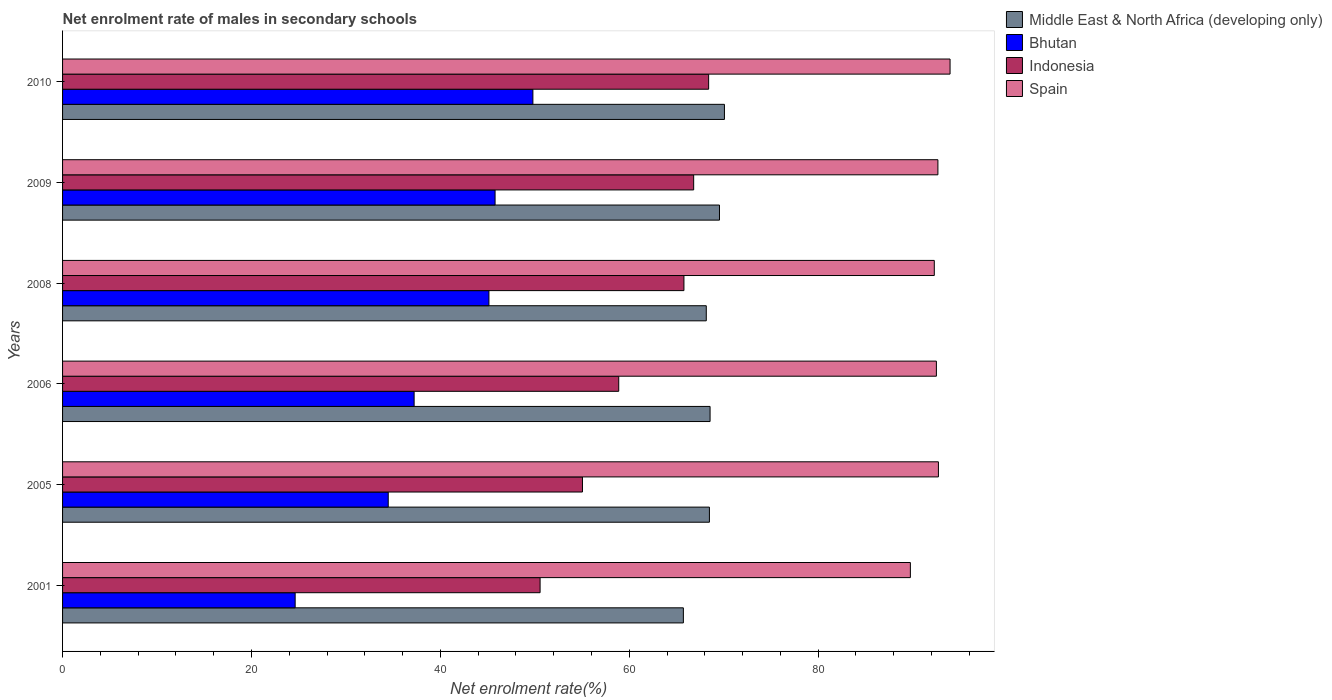How many groups of bars are there?
Provide a succinct answer. 6. Are the number of bars per tick equal to the number of legend labels?
Your response must be concise. Yes. Are the number of bars on each tick of the Y-axis equal?
Keep it short and to the point. Yes. What is the net enrolment rate of males in secondary schools in Bhutan in 2005?
Ensure brevity in your answer.  34.48. Across all years, what is the maximum net enrolment rate of males in secondary schools in Spain?
Your response must be concise. 93.97. Across all years, what is the minimum net enrolment rate of males in secondary schools in Indonesia?
Make the answer very short. 50.56. What is the total net enrolment rate of males in secondary schools in Indonesia in the graph?
Your answer should be very brief. 365.52. What is the difference between the net enrolment rate of males in secondary schools in Bhutan in 2006 and that in 2010?
Provide a succinct answer. -12.57. What is the difference between the net enrolment rate of males in secondary schools in Bhutan in 2005 and the net enrolment rate of males in secondary schools in Middle East & North Africa (developing only) in 2009?
Ensure brevity in your answer.  -35.07. What is the average net enrolment rate of males in secondary schools in Indonesia per year?
Your response must be concise. 60.92. In the year 2001, what is the difference between the net enrolment rate of males in secondary schools in Middle East & North Africa (developing only) and net enrolment rate of males in secondary schools in Bhutan?
Provide a succinct answer. 41.11. In how many years, is the net enrolment rate of males in secondary schools in Spain greater than 92 %?
Keep it short and to the point. 5. What is the ratio of the net enrolment rate of males in secondary schools in Middle East & North Africa (developing only) in 2005 to that in 2010?
Your answer should be very brief. 0.98. What is the difference between the highest and the second highest net enrolment rate of males in secondary schools in Indonesia?
Provide a short and direct response. 1.59. What is the difference between the highest and the lowest net enrolment rate of males in secondary schools in Spain?
Provide a short and direct response. 4.2. Is it the case that in every year, the sum of the net enrolment rate of males in secondary schools in Middle East & North Africa (developing only) and net enrolment rate of males in secondary schools in Spain is greater than the sum of net enrolment rate of males in secondary schools in Bhutan and net enrolment rate of males in secondary schools in Indonesia?
Your answer should be compact. Yes. What does the 3rd bar from the top in 2009 represents?
Ensure brevity in your answer.  Bhutan. What does the 1st bar from the bottom in 2009 represents?
Offer a terse response. Middle East & North Africa (developing only). How many bars are there?
Offer a very short reply. 24. What is the difference between two consecutive major ticks on the X-axis?
Offer a terse response. 20. Does the graph contain grids?
Provide a short and direct response. No. Where does the legend appear in the graph?
Offer a terse response. Top right. How many legend labels are there?
Your answer should be very brief. 4. How are the legend labels stacked?
Your answer should be compact. Vertical. What is the title of the graph?
Provide a short and direct response. Net enrolment rate of males in secondary schools. What is the label or title of the X-axis?
Make the answer very short. Net enrolment rate(%). What is the label or title of the Y-axis?
Your answer should be compact. Years. What is the Net enrolment rate(%) in Middle East & North Africa (developing only) in 2001?
Your answer should be very brief. 65.73. What is the Net enrolment rate(%) of Bhutan in 2001?
Provide a succinct answer. 24.63. What is the Net enrolment rate(%) in Indonesia in 2001?
Your response must be concise. 50.56. What is the Net enrolment rate(%) in Spain in 2001?
Your answer should be very brief. 89.77. What is the Net enrolment rate(%) of Middle East & North Africa (developing only) in 2005?
Your response must be concise. 68.49. What is the Net enrolment rate(%) of Bhutan in 2005?
Offer a terse response. 34.48. What is the Net enrolment rate(%) in Indonesia in 2005?
Your response must be concise. 55.05. What is the Net enrolment rate(%) of Spain in 2005?
Provide a succinct answer. 92.74. What is the Net enrolment rate(%) of Middle East & North Africa (developing only) in 2006?
Offer a very short reply. 68.56. What is the Net enrolment rate(%) of Bhutan in 2006?
Your response must be concise. 37.22. What is the Net enrolment rate(%) of Indonesia in 2006?
Give a very brief answer. 58.89. What is the Net enrolment rate(%) of Spain in 2006?
Offer a very short reply. 92.52. What is the Net enrolment rate(%) of Middle East & North Africa (developing only) in 2008?
Provide a succinct answer. 68.16. What is the Net enrolment rate(%) in Bhutan in 2008?
Provide a succinct answer. 45.15. What is the Net enrolment rate(%) in Indonesia in 2008?
Offer a very short reply. 65.79. What is the Net enrolment rate(%) of Spain in 2008?
Your answer should be very brief. 92.3. What is the Net enrolment rate(%) of Middle East & North Africa (developing only) in 2009?
Offer a terse response. 69.56. What is the Net enrolment rate(%) in Bhutan in 2009?
Keep it short and to the point. 45.8. What is the Net enrolment rate(%) of Indonesia in 2009?
Ensure brevity in your answer.  66.82. What is the Net enrolment rate(%) of Spain in 2009?
Your response must be concise. 92.68. What is the Net enrolment rate(%) in Middle East & North Africa (developing only) in 2010?
Make the answer very short. 70.08. What is the Net enrolment rate(%) in Bhutan in 2010?
Provide a succinct answer. 49.8. What is the Net enrolment rate(%) in Indonesia in 2010?
Make the answer very short. 68.41. What is the Net enrolment rate(%) of Spain in 2010?
Keep it short and to the point. 93.97. Across all years, what is the maximum Net enrolment rate(%) of Middle East & North Africa (developing only)?
Offer a very short reply. 70.08. Across all years, what is the maximum Net enrolment rate(%) of Bhutan?
Keep it short and to the point. 49.8. Across all years, what is the maximum Net enrolment rate(%) in Indonesia?
Make the answer very short. 68.41. Across all years, what is the maximum Net enrolment rate(%) of Spain?
Offer a very short reply. 93.97. Across all years, what is the minimum Net enrolment rate(%) in Middle East & North Africa (developing only)?
Provide a short and direct response. 65.73. Across all years, what is the minimum Net enrolment rate(%) of Bhutan?
Your response must be concise. 24.63. Across all years, what is the minimum Net enrolment rate(%) in Indonesia?
Provide a short and direct response. 50.56. Across all years, what is the minimum Net enrolment rate(%) in Spain?
Your answer should be compact. 89.77. What is the total Net enrolment rate(%) in Middle East & North Africa (developing only) in the graph?
Your answer should be compact. 410.58. What is the total Net enrolment rate(%) of Bhutan in the graph?
Your answer should be very brief. 237.07. What is the total Net enrolment rate(%) in Indonesia in the graph?
Offer a very short reply. 365.52. What is the total Net enrolment rate(%) of Spain in the graph?
Provide a short and direct response. 553.99. What is the difference between the Net enrolment rate(%) of Middle East & North Africa (developing only) in 2001 and that in 2005?
Your answer should be very brief. -2.76. What is the difference between the Net enrolment rate(%) in Bhutan in 2001 and that in 2005?
Offer a very short reply. -9.86. What is the difference between the Net enrolment rate(%) in Indonesia in 2001 and that in 2005?
Offer a terse response. -4.49. What is the difference between the Net enrolment rate(%) in Spain in 2001 and that in 2005?
Your response must be concise. -2.97. What is the difference between the Net enrolment rate(%) of Middle East & North Africa (developing only) in 2001 and that in 2006?
Your answer should be compact. -2.83. What is the difference between the Net enrolment rate(%) of Bhutan in 2001 and that in 2006?
Your answer should be very brief. -12.6. What is the difference between the Net enrolment rate(%) in Indonesia in 2001 and that in 2006?
Your response must be concise. -8.33. What is the difference between the Net enrolment rate(%) of Spain in 2001 and that in 2006?
Offer a terse response. -2.76. What is the difference between the Net enrolment rate(%) in Middle East & North Africa (developing only) in 2001 and that in 2008?
Provide a short and direct response. -2.43. What is the difference between the Net enrolment rate(%) in Bhutan in 2001 and that in 2008?
Offer a terse response. -20.52. What is the difference between the Net enrolment rate(%) of Indonesia in 2001 and that in 2008?
Your answer should be very brief. -15.23. What is the difference between the Net enrolment rate(%) in Spain in 2001 and that in 2008?
Provide a short and direct response. -2.53. What is the difference between the Net enrolment rate(%) of Middle East & North Africa (developing only) in 2001 and that in 2009?
Your answer should be very brief. -3.82. What is the difference between the Net enrolment rate(%) of Bhutan in 2001 and that in 2009?
Ensure brevity in your answer.  -21.17. What is the difference between the Net enrolment rate(%) in Indonesia in 2001 and that in 2009?
Give a very brief answer. -16.26. What is the difference between the Net enrolment rate(%) in Spain in 2001 and that in 2009?
Your answer should be very brief. -2.92. What is the difference between the Net enrolment rate(%) in Middle East & North Africa (developing only) in 2001 and that in 2010?
Keep it short and to the point. -4.35. What is the difference between the Net enrolment rate(%) in Bhutan in 2001 and that in 2010?
Ensure brevity in your answer.  -25.17. What is the difference between the Net enrolment rate(%) of Indonesia in 2001 and that in 2010?
Give a very brief answer. -17.85. What is the difference between the Net enrolment rate(%) in Spain in 2001 and that in 2010?
Make the answer very short. -4.2. What is the difference between the Net enrolment rate(%) of Middle East & North Africa (developing only) in 2005 and that in 2006?
Give a very brief answer. -0.07. What is the difference between the Net enrolment rate(%) in Bhutan in 2005 and that in 2006?
Provide a succinct answer. -2.74. What is the difference between the Net enrolment rate(%) of Indonesia in 2005 and that in 2006?
Give a very brief answer. -3.84. What is the difference between the Net enrolment rate(%) of Spain in 2005 and that in 2006?
Offer a very short reply. 0.21. What is the difference between the Net enrolment rate(%) in Middle East & North Africa (developing only) in 2005 and that in 2008?
Your answer should be very brief. 0.33. What is the difference between the Net enrolment rate(%) of Bhutan in 2005 and that in 2008?
Offer a terse response. -10.66. What is the difference between the Net enrolment rate(%) of Indonesia in 2005 and that in 2008?
Provide a short and direct response. -10.74. What is the difference between the Net enrolment rate(%) in Spain in 2005 and that in 2008?
Your response must be concise. 0.44. What is the difference between the Net enrolment rate(%) in Middle East & North Africa (developing only) in 2005 and that in 2009?
Offer a very short reply. -1.07. What is the difference between the Net enrolment rate(%) in Bhutan in 2005 and that in 2009?
Keep it short and to the point. -11.31. What is the difference between the Net enrolment rate(%) in Indonesia in 2005 and that in 2009?
Make the answer very short. -11.77. What is the difference between the Net enrolment rate(%) of Spain in 2005 and that in 2009?
Keep it short and to the point. 0.05. What is the difference between the Net enrolment rate(%) of Middle East & North Africa (developing only) in 2005 and that in 2010?
Offer a terse response. -1.59. What is the difference between the Net enrolment rate(%) of Bhutan in 2005 and that in 2010?
Give a very brief answer. -15.32. What is the difference between the Net enrolment rate(%) of Indonesia in 2005 and that in 2010?
Your answer should be compact. -13.36. What is the difference between the Net enrolment rate(%) of Spain in 2005 and that in 2010?
Your response must be concise. -1.23. What is the difference between the Net enrolment rate(%) in Middle East & North Africa (developing only) in 2006 and that in 2008?
Offer a terse response. 0.4. What is the difference between the Net enrolment rate(%) in Bhutan in 2006 and that in 2008?
Your response must be concise. -7.92. What is the difference between the Net enrolment rate(%) of Indonesia in 2006 and that in 2008?
Keep it short and to the point. -6.91. What is the difference between the Net enrolment rate(%) in Spain in 2006 and that in 2008?
Your answer should be compact. 0.22. What is the difference between the Net enrolment rate(%) in Middle East & North Africa (developing only) in 2006 and that in 2009?
Your answer should be compact. -1. What is the difference between the Net enrolment rate(%) in Bhutan in 2006 and that in 2009?
Make the answer very short. -8.57. What is the difference between the Net enrolment rate(%) of Indonesia in 2006 and that in 2009?
Your answer should be compact. -7.93. What is the difference between the Net enrolment rate(%) of Spain in 2006 and that in 2009?
Provide a succinct answer. -0.16. What is the difference between the Net enrolment rate(%) of Middle East & North Africa (developing only) in 2006 and that in 2010?
Your answer should be very brief. -1.52. What is the difference between the Net enrolment rate(%) in Bhutan in 2006 and that in 2010?
Your answer should be compact. -12.57. What is the difference between the Net enrolment rate(%) of Indonesia in 2006 and that in 2010?
Your response must be concise. -9.52. What is the difference between the Net enrolment rate(%) in Spain in 2006 and that in 2010?
Keep it short and to the point. -1.45. What is the difference between the Net enrolment rate(%) in Middle East & North Africa (developing only) in 2008 and that in 2009?
Provide a short and direct response. -1.4. What is the difference between the Net enrolment rate(%) of Bhutan in 2008 and that in 2009?
Offer a very short reply. -0.65. What is the difference between the Net enrolment rate(%) in Indonesia in 2008 and that in 2009?
Ensure brevity in your answer.  -1.03. What is the difference between the Net enrolment rate(%) of Spain in 2008 and that in 2009?
Keep it short and to the point. -0.38. What is the difference between the Net enrolment rate(%) of Middle East & North Africa (developing only) in 2008 and that in 2010?
Provide a succinct answer. -1.92. What is the difference between the Net enrolment rate(%) in Bhutan in 2008 and that in 2010?
Keep it short and to the point. -4.65. What is the difference between the Net enrolment rate(%) of Indonesia in 2008 and that in 2010?
Offer a terse response. -2.62. What is the difference between the Net enrolment rate(%) in Spain in 2008 and that in 2010?
Ensure brevity in your answer.  -1.67. What is the difference between the Net enrolment rate(%) in Middle East & North Africa (developing only) in 2009 and that in 2010?
Provide a succinct answer. -0.52. What is the difference between the Net enrolment rate(%) in Bhutan in 2009 and that in 2010?
Offer a terse response. -4. What is the difference between the Net enrolment rate(%) of Indonesia in 2009 and that in 2010?
Offer a terse response. -1.59. What is the difference between the Net enrolment rate(%) in Spain in 2009 and that in 2010?
Your response must be concise. -1.29. What is the difference between the Net enrolment rate(%) in Middle East & North Africa (developing only) in 2001 and the Net enrolment rate(%) in Bhutan in 2005?
Provide a succinct answer. 31.25. What is the difference between the Net enrolment rate(%) of Middle East & North Africa (developing only) in 2001 and the Net enrolment rate(%) of Indonesia in 2005?
Your response must be concise. 10.68. What is the difference between the Net enrolment rate(%) in Middle East & North Africa (developing only) in 2001 and the Net enrolment rate(%) in Spain in 2005?
Offer a very short reply. -27.01. What is the difference between the Net enrolment rate(%) in Bhutan in 2001 and the Net enrolment rate(%) in Indonesia in 2005?
Offer a terse response. -30.42. What is the difference between the Net enrolment rate(%) in Bhutan in 2001 and the Net enrolment rate(%) in Spain in 2005?
Give a very brief answer. -68.11. What is the difference between the Net enrolment rate(%) of Indonesia in 2001 and the Net enrolment rate(%) of Spain in 2005?
Give a very brief answer. -42.18. What is the difference between the Net enrolment rate(%) of Middle East & North Africa (developing only) in 2001 and the Net enrolment rate(%) of Bhutan in 2006?
Provide a short and direct response. 28.51. What is the difference between the Net enrolment rate(%) in Middle East & North Africa (developing only) in 2001 and the Net enrolment rate(%) in Indonesia in 2006?
Keep it short and to the point. 6.84. What is the difference between the Net enrolment rate(%) of Middle East & North Africa (developing only) in 2001 and the Net enrolment rate(%) of Spain in 2006?
Ensure brevity in your answer.  -26.79. What is the difference between the Net enrolment rate(%) of Bhutan in 2001 and the Net enrolment rate(%) of Indonesia in 2006?
Ensure brevity in your answer.  -34.26. What is the difference between the Net enrolment rate(%) in Bhutan in 2001 and the Net enrolment rate(%) in Spain in 2006?
Give a very brief answer. -67.9. What is the difference between the Net enrolment rate(%) of Indonesia in 2001 and the Net enrolment rate(%) of Spain in 2006?
Offer a very short reply. -41.96. What is the difference between the Net enrolment rate(%) in Middle East & North Africa (developing only) in 2001 and the Net enrolment rate(%) in Bhutan in 2008?
Provide a short and direct response. 20.59. What is the difference between the Net enrolment rate(%) of Middle East & North Africa (developing only) in 2001 and the Net enrolment rate(%) of Indonesia in 2008?
Keep it short and to the point. -0.06. What is the difference between the Net enrolment rate(%) in Middle East & North Africa (developing only) in 2001 and the Net enrolment rate(%) in Spain in 2008?
Make the answer very short. -26.57. What is the difference between the Net enrolment rate(%) of Bhutan in 2001 and the Net enrolment rate(%) of Indonesia in 2008?
Provide a succinct answer. -41.17. What is the difference between the Net enrolment rate(%) of Bhutan in 2001 and the Net enrolment rate(%) of Spain in 2008?
Offer a terse response. -67.67. What is the difference between the Net enrolment rate(%) in Indonesia in 2001 and the Net enrolment rate(%) in Spain in 2008?
Your response must be concise. -41.74. What is the difference between the Net enrolment rate(%) of Middle East & North Africa (developing only) in 2001 and the Net enrolment rate(%) of Bhutan in 2009?
Keep it short and to the point. 19.94. What is the difference between the Net enrolment rate(%) of Middle East & North Africa (developing only) in 2001 and the Net enrolment rate(%) of Indonesia in 2009?
Give a very brief answer. -1.09. What is the difference between the Net enrolment rate(%) in Middle East & North Africa (developing only) in 2001 and the Net enrolment rate(%) in Spain in 2009?
Offer a very short reply. -26.95. What is the difference between the Net enrolment rate(%) in Bhutan in 2001 and the Net enrolment rate(%) in Indonesia in 2009?
Offer a terse response. -42.2. What is the difference between the Net enrolment rate(%) of Bhutan in 2001 and the Net enrolment rate(%) of Spain in 2009?
Keep it short and to the point. -68.06. What is the difference between the Net enrolment rate(%) in Indonesia in 2001 and the Net enrolment rate(%) in Spain in 2009?
Your response must be concise. -42.12. What is the difference between the Net enrolment rate(%) in Middle East & North Africa (developing only) in 2001 and the Net enrolment rate(%) in Bhutan in 2010?
Your answer should be very brief. 15.93. What is the difference between the Net enrolment rate(%) in Middle East & North Africa (developing only) in 2001 and the Net enrolment rate(%) in Indonesia in 2010?
Ensure brevity in your answer.  -2.68. What is the difference between the Net enrolment rate(%) in Middle East & North Africa (developing only) in 2001 and the Net enrolment rate(%) in Spain in 2010?
Offer a terse response. -28.24. What is the difference between the Net enrolment rate(%) of Bhutan in 2001 and the Net enrolment rate(%) of Indonesia in 2010?
Provide a succinct answer. -43.78. What is the difference between the Net enrolment rate(%) in Bhutan in 2001 and the Net enrolment rate(%) in Spain in 2010?
Your answer should be very brief. -69.34. What is the difference between the Net enrolment rate(%) of Indonesia in 2001 and the Net enrolment rate(%) of Spain in 2010?
Your answer should be very brief. -43.41. What is the difference between the Net enrolment rate(%) of Middle East & North Africa (developing only) in 2005 and the Net enrolment rate(%) of Bhutan in 2006?
Your answer should be compact. 31.27. What is the difference between the Net enrolment rate(%) of Middle East & North Africa (developing only) in 2005 and the Net enrolment rate(%) of Indonesia in 2006?
Give a very brief answer. 9.6. What is the difference between the Net enrolment rate(%) in Middle East & North Africa (developing only) in 2005 and the Net enrolment rate(%) in Spain in 2006?
Provide a succinct answer. -24.03. What is the difference between the Net enrolment rate(%) of Bhutan in 2005 and the Net enrolment rate(%) of Indonesia in 2006?
Your answer should be very brief. -24.4. What is the difference between the Net enrolment rate(%) in Bhutan in 2005 and the Net enrolment rate(%) in Spain in 2006?
Offer a very short reply. -58.04. What is the difference between the Net enrolment rate(%) in Indonesia in 2005 and the Net enrolment rate(%) in Spain in 2006?
Provide a short and direct response. -37.47. What is the difference between the Net enrolment rate(%) in Middle East & North Africa (developing only) in 2005 and the Net enrolment rate(%) in Bhutan in 2008?
Your answer should be very brief. 23.35. What is the difference between the Net enrolment rate(%) in Middle East & North Africa (developing only) in 2005 and the Net enrolment rate(%) in Indonesia in 2008?
Keep it short and to the point. 2.7. What is the difference between the Net enrolment rate(%) of Middle East & North Africa (developing only) in 2005 and the Net enrolment rate(%) of Spain in 2008?
Offer a very short reply. -23.81. What is the difference between the Net enrolment rate(%) of Bhutan in 2005 and the Net enrolment rate(%) of Indonesia in 2008?
Make the answer very short. -31.31. What is the difference between the Net enrolment rate(%) in Bhutan in 2005 and the Net enrolment rate(%) in Spain in 2008?
Keep it short and to the point. -57.82. What is the difference between the Net enrolment rate(%) in Indonesia in 2005 and the Net enrolment rate(%) in Spain in 2008?
Make the answer very short. -37.25. What is the difference between the Net enrolment rate(%) of Middle East & North Africa (developing only) in 2005 and the Net enrolment rate(%) of Bhutan in 2009?
Your answer should be compact. 22.7. What is the difference between the Net enrolment rate(%) in Middle East & North Africa (developing only) in 2005 and the Net enrolment rate(%) in Indonesia in 2009?
Give a very brief answer. 1.67. What is the difference between the Net enrolment rate(%) in Middle East & North Africa (developing only) in 2005 and the Net enrolment rate(%) in Spain in 2009?
Offer a terse response. -24.19. What is the difference between the Net enrolment rate(%) in Bhutan in 2005 and the Net enrolment rate(%) in Indonesia in 2009?
Make the answer very short. -32.34. What is the difference between the Net enrolment rate(%) of Bhutan in 2005 and the Net enrolment rate(%) of Spain in 2009?
Your response must be concise. -58.2. What is the difference between the Net enrolment rate(%) of Indonesia in 2005 and the Net enrolment rate(%) of Spain in 2009?
Offer a very short reply. -37.63. What is the difference between the Net enrolment rate(%) in Middle East & North Africa (developing only) in 2005 and the Net enrolment rate(%) in Bhutan in 2010?
Give a very brief answer. 18.69. What is the difference between the Net enrolment rate(%) of Middle East & North Africa (developing only) in 2005 and the Net enrolment rate(%) of Indonesia in 2010?
Your response must be concise. 0.08. What is the difference between the Net enrolment rate(%) in Middle East & North Africa (developing only) in 2005 and the Net enrolment rate(%) in Spain in 2010?
Provide a short and direct response. -25.48. What is the difference between the Net enrolment rate(%) of Bhutan in 2005 and the Net enrolment rate(%) of Indonesia in 2010?
Make the answer very short. -33.93. What is the difference between the Net enrolment rate(%) in Bhutan in 2005 and the Net enrolment rate(%) in Spain in 2010?
Your response must be concise. -59.49. What is the difference between the Net enrolment rate(%) of Indonesia in 2005 and the Net enrolment rate(%) of Spain in 2010?
Ensure brevity in your answer.  -38.92. What is the difference between the Net enrolment rate(%) of Middle East & North Africa (developing only) in 2006 and the Net enrolment rate(%) of Bhutan in 2008?
Your answer should be compact. 23.42. What is the difference between the Net enrolment rate(%) of Middle East & North Africa (developing only) in 2006 and the Net enrolment rate(%) of Indonesia in 2008?
Your response must be concise. 2.77. What is the difference between the Net enrolment rate(%) of Middle East & North Africa (developing only) in 2006 and the Net enrolment rate(%) of Spain in 2008?
Offer a very short reply. -23.74. What is the difference between the Net enrolment rate(%) in Bhutan in 2006 and the Net enrolment rate(%) in Indonesia in 2008?
Offer a very short reply. -28.57. What is the difference between the Net enrolment rate(%) in Bhutan in 2006 and the Net enrolment rate(%) in Spain in 2008?
Offer a very short reply. -55.08. What is the difference between the Net enrolment rate(%) in Indonesia in 2006 and the Net enrolment rate(%) in Spain in 2008?
Keep it short and to the point. -33.41. What is the difference between the Net enrolment rate(%) in Middle East & North Africa (developing only) in 2006 and the Net enrolment rate(%) in Bhutan in 2009?
Give a very brief answer. 22.77. What is the difference between the Net enrolment rate(%) in Middle East & North Africa (developing only) in 2006 and the Net enrolment rate(%) in Indonesia in 2009?
Provide a short and direct response. 1.74. What is the difference between the Net enrolment rate(%) in Middle East & North Africa (developing only) in 2006 and the Net enrolment rate(%) in Spain in 2009?
Offer a very short reply. -24.12. What is the difference between the Net enrolment rate(%) in Bhutan in 2006 and the Net enrolment rate(%) in Indonesia in 2009?
Give a very brief answer. -29.6. What is the difference between the Net enrolment rate(%) in Bhutan in 2006 and the Net enrolment rate(%) in Spain in 2009?
Offer a terse response. -55.46. What is the difference between the Net enrolment rate(%) in Indonesia in 2006 and the Net enrolment rate(%) in Spain in 2009?
Provide a succinct answer. -33.8. What is the difference between the Net enrolment rate(%) in Middle East & North Africa (developing only) in 2006 and the Net enrolment rate(%) in Bhutan in 2010?
Your answer should be very brief. 18.76. What is the difference between the Net enrolment rate(%) in Middle East & North Africa (developing only) in 2006 and the Net enrolment rate(%) in Indonesia in 2010?
Make the answer very short. 0.15. What is the difference between the Net enrolment rate(%) of Middle East & North Africa (developing only) in 2006 and the Net enrolment rate(%) of Spain in 2010?
Ensure brevity in your answer.  -25.41. What is the difference between the Net enrolment rate(%) in Bhutan in 2006 and the Net enrolment rate(%) in Indonesia in 2010?
Offer a very short reply. -31.18. What is the difference between the Net enrolment rate(%) in Bhutan in 2006 and the Net enrolment rate(%) in Spain in 2010?
Your answer should be compact. -56.75. What is the difference between the Net enrolment rate(%) of Indonesia in 2006 and the Net enrolment rate(%) of Spain in 2010?
Keep it short and to the point. -35.08. What is the difference between the Net enrolment rate(%) of Middle East & North Africa (developing only) in 2008 and the Net enrolment rate(%) of Bhutan in 2009?
Your answer should be compact. 22.36. What is the difference between the Net enrolment rate(%) of Middle East & North Africa (developing only) in 2008 and the Net enrolment rate(%) of Indonesia in 2009?
Your response must be concise. 1.34. What is the difference between the Net enrolment rate(%) in Middle East & North Africa (developing only) in 2008 and the Net enrolment rate(%) in Spain in 2009?
Offer a very short reply. -24.53. What is the difference between the Net enrolment rate(%) in Bhutan in 2008 and the Net enrolment rate(%) in Indonesia in 2009?
Your answer should be compact. -21.68. What is the difference between the Net enrolment rate(%) of Bhutan in 2008 and the Net enrolment rate(%) of Spain in 2009?
Ensure brevity in your answer.  -47.54. What is the difference between the Net enrolment rate(%) in Indonesia in 2008 and the Net enrolment rate(%) in Spain in 2009?
Provide a succinct answer. -26.89. What is the difference between the Net enrolment rate(%) of Middle East & North Africa (developing only) in 2008 and the Net enrolment rate(%) of Bhutan in 2010?
Your answer should be very brief. 18.36. What is the difference between the Net enrolment rate(%) in Middle East & North Africa (developing only) in 2008 and the Net enrolment rate(%) in Indonesia in 2010?
Provide a succinct answer. -0.25. What is the difference between the Net enrolment rate(%) in Middle East & North Africa (developing only) in 2008 and the Net enrolment rate(%) in Spain in 2010?
Keep it short and to the point. -25.81. What is the difference between the Net enrolment rate(%) of Bhutan in 2008 and the Net enrolment rate(%) of Indonesia in 2010?
Your answer should be compact. -23.26. What is the difference between the Net enrolment rate(%) in Bhutan in 2008 and the Net enrolment rate(%) in Spain in 2010?
Offer a terse response. -48.83. What is the difference between the Net enrolment rate(%) of Indonesia in 2008 and the Net enrolment rate(%) of Spain in 2010?
Your response must be concise. -28.18. What is the difference between the Net enrolment rate(%) of Middle East & North Africa (developing only) in 2009 and the Net enrolment rate(%) of Bhutan in 2010?
Ensure brevity in your answer.  19.76. What is the difference between the Net enrolment rate(%) of Middle East & North Africa (developing only) in 2009 and the Net enrolment rate(%) of Indonesia in 2010?
Ensure brevity in your answer.  1.15. What is the difference between the Net enrolment rate(%) of Middle East & North Africa (developing only) in 2009 and the Net enrolment rate(%) of Spain in 2010?
Your answer should be very brief. -24.41. What is the difference between the Net enrolment rate(%) in Bhutan in 2009 and the Net enrolment rate(%) in Indonesia in 2010?
Offer a very short reply. -22.61. What is the difference between the Net enrolment rate(%) in Bhutan in 2009 and the Net enrolment rate(%) in Spain in 2010?
Provide a short and direct response. -48.18. What is the difference between the Net enrolment rate(%) in Indonesia in 2009 and the Net enrolment rate(%) in Spain in 2010?
Ensure brevity in your answer.  -27.15. What is the average Net enrolment rate(%) of Middle East & North Africa (developing only) per year?
Your response must be concise. 68.43. What is the average Net enrolment rate(%) in Bhutan per year?
Your answer should be compact. 39.51. What is the average Net enrolment rate(%) in Indonesia per year?
Ensure brevity in your answer.  60.92. What is the average Net enrolment rate(%) in Spain per year?
Ensure brevity in your answer.  92.33. In the year 2001, what is the difference between the Net enrolment rate(%) of Middle East & North Africa (developing only) and Net enrolment rate(%) of Bhutan?
Give a very brief answer. 41.11. In the year 2001, what is the difference between the Net enrolment rate(%) in Middle East & North Africa (developing only) and Net enrolment rate(%) in Indonesia?
Provide a short and direct response. 15.17. In the year 2001, what is the difference between the Net enrolment rate(%) in Middle East & North Africa (developing only) and Net enrolment rate(%) in Spain?
Offer a very short reply. -24.04. In the year 2001, what is the difference between the Net enrolment rate(%) of Bhutan and Net enrolment rate(%) of Indonesia?
Your response must be concise. -25.93. In the year 2001, what is the difference between the Net enrolment rate(%) of Bhutan and Net enrolment rate(%) of Spain?
Offer a terse response. -65.14. In the year 2001, what is the difference between the Net enrolment rate(%) of Indonesia and Net enrolment rate(%) of Spain?
Offer a very short reply. -39.21. In the year 2005, what is the difference between the Net enrolment rate(%) of Middle East & North Africa (developing only) and Net enrolment rate(%) of Bhutan?
Give a very brief answer. 34.01. In the year 2005, what is the difference between the Net enrolment rate(%) of Middle East & North Africa (developing only) and Net enrolment rate(%) of Indonesia?
Your answer should be very brief. 13.44. In the year 2005, what is the difference between the Net enrolment rate(%) in Middle East & North Africa (developing only) and Net enrolment rate(%) in Spain?
Give a very brief answer. -24.25. In the year 2005, what is the difference between the Net enrolment rate(%) of Bhutan and Net enrolment rate(%) of Indonesia?
Offer a terse response. -20.57. In the year 2005, what is the difference between the Net enrolment rate(%) of Bhutan and Net enrolment rate(%) of Spain?
Your response must be concise. -58.25. In the year 2005, what is the difference between the Net enrolment rate(%) of Indonesia and Net enrolment rate(%) of Spain?
Your response must be concise. -37.69. In the year 2006, what is the difference between the Net enrolment rate(%) in Middle East & North Africa (developing only) and Net enrolment rate(%) in Bhutan?
Make the answer very short. 31.34. In the year 2006, what is the difference between the Net enrolment rate(%) in Middle East & North Africa (developing only) and Net enrolment rate(%) in Indonesia?
Ensure brevity in your answer.  9.67. In the year 2006, what is the difference between the Net enrolment rate(%) of Middle East & North Africa (developing only) and Net enrolment rate(%) of Spain?
Give a very brief answer. -23.96. In the year 2006, what is the difference between the Net enrolment rate(%) of Bhutan and Net enrolment rate(%) of Indonesia?
Ensure brevity in your answer.  -21.66. In the year 2006, what is the difference between the Net enrolment rate(%) in Bhutan and Net enrolment rate(%) in Spain?
Provide a succinct answer. -55.3. In the year 2006, what is the difference between the Net enrolment rate(%) in Indonesia and Net enrolment rate(%) in Spain?
Your answer should be very brief. -33.64. In the year 2008, what is the difference between the Net enrolment rate(%) of Middle East & North Africa (developing only) and Net enrolment rate(%) of Bhutan?
Give a very brief answer. 23.01. In the year 2008, what is the difference between the Net enrolment rate(%) in Middle East & North Africa (developing only) and Net enrolment rate(%) in Indonesia?
Make the answer very short. 2.37. In the year 2008, what is the difference between the Net enrolment rate(%) in Middle East & North Africa (developing only) and Net enrolment rate(%) in Spain?
Offer a terse response. -24.14. In the year 2008, what is the difference between the Net enrolment rate(%) of Bhutan and Net enrolment rate(%) of Indonesia?
Make the answer very short. -20.65. In the year 2008, what is the difference between the Net enrolment rate(%) of Bhutan and Net enrolment rate(%) of Spain?
Your answer should be very brief. -47.16. In the year 2008, what is the difference between the Net enrolment rate(%) in Indonesia and Net enrolment rate(%) in Spain?
Your answer should be very brief. -26.51. In the year 2009, what is the difference between the Net enrolment rate(%) of Middle East & North Africa (developing only) and Net enrolment rate(%) of Bhutan?
Give a very brief answer. 23.76. In the year 2009, what is the difference between the Net enrolment rate(%) of Middle East & North Africa (developing only) and Net enrolment rate(%) of Indonesia?
Your answer should be compact. 2.73. In the year 2009, what is the difference between the Net enrolment rate(%) in Middle East & North Africa (developing only) and Net enrolment rate(%) in Spain?
Your answer should be very brief. -23.13. In the year 2009, what is the difference between the Net enrolment rate(%) in Bhutan and Net enrolment rate(%) in Indonesia?
Offer a very short reply. -21.03. In the year 2009, what is the difference between the Net enrolment rate(%) of Bhutan and Net enrolment rate(%) of Spain?
Offer a terse response. -46.89. In the year 2009, what is the difference between the Net enrolment rate(%) of Indonesia and Net enrolment rate(%) of Spain?
Keep it short and to the point. -25.86. In the year 2010, what is the difference between the Net enrolment rate(%) of Middle East & North Africa (developing only) and Net enrolment rate(%) of Bhutan?
Provide a short and direct response. 20.28. In the year 2010, what is the difference between the Net enrolment rate(%) in Middle East & North Africa (developing only) and Net enrolment rate(%) in Indonesia?
Your response must be concise. 1.67. In the year 2010, what is the difference between the Net enrolment rate(%) of Middle East & North Africa (developing only) and Net enrolment rate(%) of Spain?
Offer a very short reply. -23.89. In the year 2010, what is the difference between the Net enrolment rate(%) of Bhutan and Net enrolment rate(%) of Indonesia?
Your answer should be very brief. -18.61. In the year 2010, what is the difference between the Net enrolment rate(%) of Bhutan and Net enrolment rate(%) of Spain?
Provide a succinct answer. -44.17. In the year 2010, what is the difference between the Net enrolment rate(%) of Indonesia and Net enrolment rate(%) of Spain?
Keep it short and to the point. -25.56. What is the ratio of the Net enrolment rate(%) of Middle East & North Africa (developing only) in 2001 to that in 2005?
Ensure brevity in your answer.  0.96. What is the ratio of the Net enrolment rate(%) of Bhutan in 2001 to that in 2005?
Offer a very short reply. 0.71. What is the ratio of the Net enrolment rate(%) in Indonesia in 2001 to that in 2005?
Your answer should be very brief. 0.92. What is the ratio of the Net enrolment rate(%) in Spain in 2001 to that in 2005?
Provide a succinct answer. 0.97. What is the ratio of the Net enrolment rate(%) in Middle East & North Africa (developing only) in 2001 to that in 2006?
Your response must be concise. 0.96. What is the ratio of the Net enrolment rate(%) of Bhutan in 2001 to that in 2006?
Your response must be concise. 0.66. What is the ratio of the Net enrolment rate(%) in Indonesia in 2001 to that in 2006?
Your answer should be very brief. 0.86. What is the ratio of the Net enrolment rate(%) of Spain in 2001 to that in 2006?
Your answer should be very brief. 0.97. What is the ratio of the Net enrolment rate(%) of Middle East & North Africa (developing only) in 2001 to that in 2008?
Your answer should be compact. 0.96. What is the ratio of the Net enrolment rate(%) in Bhutan in 2001 to that in 2008?
Give a very brief answer. 0.55. What is the ratio of the Net enrolment rate(%) of Indonesia in 2001 to that in 2008?
Provide a succinct answer. 0.77. What is the ratio of the Net enrolment rate(%) of Spain in 2001 to that in 2008?
Provide a succinct answer. 0.97. What is the ratio of the Net enrolment rate(%) of Middle East & North Africa (developing only) in 2001 to that in 2009?
Your answer should be compact. 0.94. What is the ratio of the Net enrolment rate(%) of Bhutan in 2001 to that in 2009?
Give a very brief answer. 0.54. What is the ratio of the Net enrolment rate(%) in Indonesia in 2001 to that in 2009?
Your response must be concise. 0.76. What is the ratio of the Net enrolment rate(%) in Spain in 2001 to that in 2009?
Your answer should be compact. 0.97. What is the ratio of the Net enrolment rate(%) of Middle East & North Africa (developing only) in 2001 to that in 2010?
Keep it short and to the point. 0.94. What is the ratio of the Net enrolment rate(%) in Bhutan in 2001 to that in 2010?
Your response must be concise. 0.49. What is the ratio of the Net enrolment rate(%) of Indonesia in 2001 to that in 2010?
Ensure brevity in your answer.  0.74. What is the ratio of the Net enrolment rate(%) in Spain in 2001 to that in 2010?
Keep it short and to the point. 0.96. What is the ratio of the Net enrolment rate(%) in Bhutan in 2005 to that in 2006?
Provide a short and direct response. 0.93. What is the ratio of the Net enrolment rate(%) of Indonesia in 2005 to that in 2006?
Give a very brief answer. 0.93. What is the ratio of the Net enrolment rate(%) in Spain in 2005 to that in 2006?
Offer a terse response. 1. What is the ratio of the Net enrolment rate(%) of Bhutan in 2005 to that in 2008?
Make the answer very short. 0.76. What is the ratio of the Net enrolment rate(%) of Indonesia in 2005 to that in 2008?
Ensure brevity in your answer.  0.84. What is the ratio of the Net enrolment rate(%) of Spain in 2005 to that in 2008?
Give a very brief answer. 1. What is the ratio of the Net enrolment rate(%) in Middle East & North Africa (developing only) in 2005 to that in 2009?
Ensure brevity in your answer.  0.98. What is the ratio of the Net enrolment rate(%) of Bhutan in 2005 to that in 2009?
Your answer should be very brief. 0.75. What is the ratio of the Net enrolment rate(%) in Indonesia in 2005 to that in 2009?
Offer a terse response. 0.82. What is the ratio of the Net enrolment rate(%) in Middle East & North Africa (developing only) in 2005 to that in 2010?
Give a very brief answer. 0.98. What is the ratio of the Net enrolment rate(%) of Bhutan in 2005 to that in 2010?
Keep it short and to the point. 0.69. What is the ratio of the Net enrolment rate(%) in Indonesia in 2005 to that in 2010?
Keep it short and to the point. 0.8. What is the ratio of the Net enrolment rate(%) in Spain in 2005 to that in 2010?
Ensure brevity in your answer.  0.99. What is the ratio of the Net enrolment rate(%) in Middle East & North Africa (developing only) in 2006 to that in 2008?
Your response must be concise. 1.01. What is the ratio of the Net enrolment rate(%) in Bhutan in 2006 to that in 2008?
Your answer should be very brief. 0.82. What is the ratio of the Net enrolment rate(%) in Indonesia in 2006 to that in 2008?
Offer a very short reply. 0.9. What is the ratio of the Net enrolment rate(%) of Middle East & North Africa (developing only) in 2006 to that in 2009?
Your answer should be compact. 0.99. What is the ratio of the Net enrolment rate(%) of Bhutan in 2006 to that in 2009?
Provide a succinct answer. 0.81. What is the ratio of the Net enrolment rate(%) of Indonesia in 2006 to that in 2009?
Your answer should be very brief. 0.88. What is the ratio of the Net enrolment rate(%) in Middle East & North Africa (developing only) in 2006 to that in 2010?
Offer a very short reply. 0.98. What is the ratio of the Net enrolment rate(%) of Bhutan in 2006 to that in 2010?
Ensure brevity in your answer.  0.75. What is the ratio of the Net enrolment rate(%) in Indonesia in 2006 to that in 2010?
Provide a succinct answer. 0.86. What is the ratio of the Net enrolment rate(%) of Spain in 2006 to that in 2010?
Provide a succinct answer. 0.98. What is the ratio of the Net enrolment rate(%) of Middle East & North Africa (developing only) in 2008 to that in 2009?
Your answer should be very brief. 0.98. What is the ratio of the Net enrolment rate(%) of Bhutan in 2008 to that in 2009?
Offer a very short reply. 0.99. What is the ratio of the Net enrolment rate(%) of Indonesia in 2008 to that in 2009?
Provide a succinct answer. 0.98. What is the ratio of the Net enrolment rate(%) of Middle East & North Africa (developing only) in 2008 to that in 2010?
Keep it short and to the point. 0.97. What is the ratio of the Net enrolment rate(%) of Bhutan in 2008 to that in 2010?
Keep it short and to the point. 0.91. What is the ratio of the Net enrolment rate(%) of Indonesia in 2008 to that in 2010?
Offer a terse response. 0.96. What is the ratio of the Net enrolment rate(%) of Spain in 2008 to that in 2010?
Your answer should be very brief. 0.98. What is the ratio of the Net enrolment rate(%) in Middle East & North Africa (developing only) in 2009 to that in 2010?
Keep it short and to the point. 0.99. What is the ratio of the Net enrolment rate(%) of Bhutan in 2009 to that in 2010?
Give a very brief answer. 0.92. What is the ratio of the Net enrolment rate(%) in Indonesia in 2009 to that in 2010?
Offer a very short reply. 0.98. What is the ratio of the Net enrolment rate(%) of Spain in 2009 to that in 2010?
Provide a succinct answer. 0.99. What is the difference between the highest and the second highest Net enrolment rate(%) in Middle East & North Africa (developing only)?
Make the answer very short. 0.52. What is the difference between the highest and the second highest Net enrolment rate(%) of Bhutan?
Provide a succinct answer. 4. What is the difference between the highest and the second highest Net enrolment rate(%) of Indonesia?
Offer a terse response. 1.59. What is the difference between the highest and the second highest Net enrolment rate(%) in Spain?
Offer a very short reply. 1.23. What is the difference between the highest and the lowest Net enrolment rate(%) in Middle East & North Africa (developing only)?
Provide a succinct answer. 4.35. What is the difference between the highest and the lowest Net enrolment rate(%) of Bhutan?
Your answer should be compact. 25.17. What is the difference between the highest and the lowest Net enrolment rate(%) of Indonesia?
Provide a succinct answer. 17.85. What is the difference between the highest and the lowest Net enrolment rate(%) of Spain?
Offer a very short reply. 4.2. 